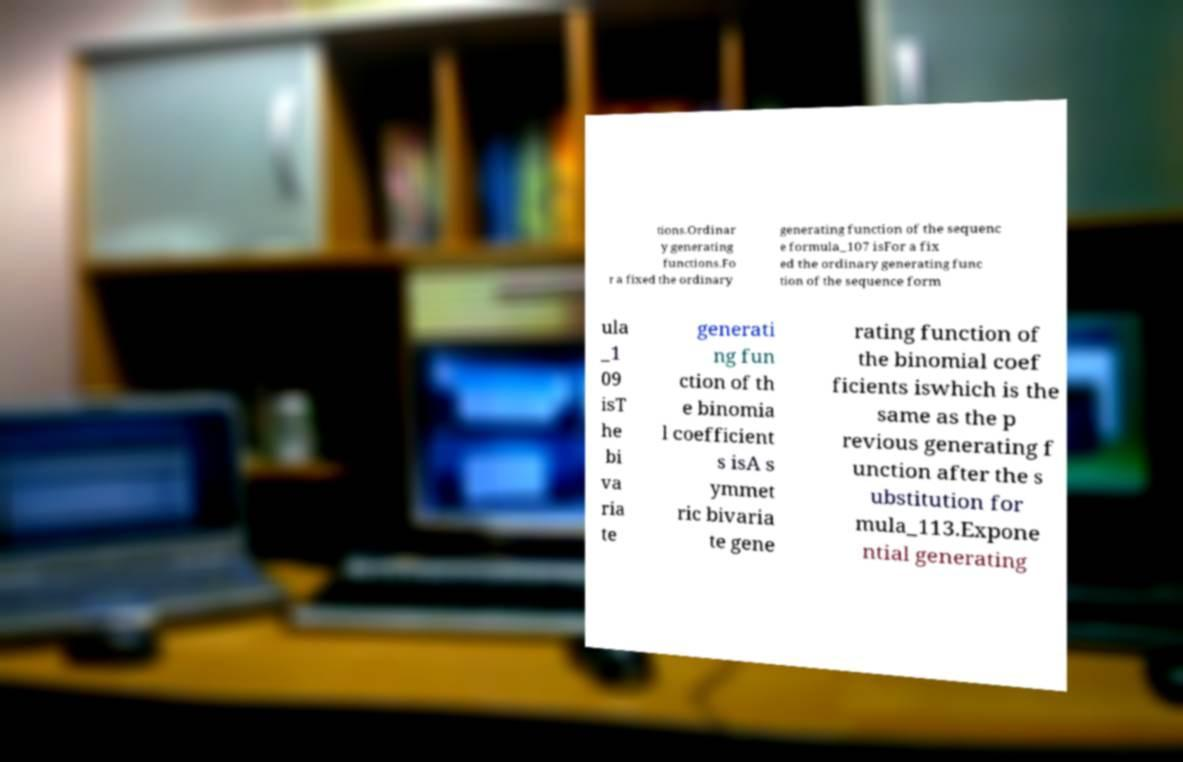Can you read and provide the text displayed in the image?This photo seems to have some interesting text. Can you extract and type it out for me? tions.Ordinar y generating functions.Fo r a fixed the ordinary generating function of the sequenc e formula_107 isFor a fix ed the ordinary generating func tion of the sequence form ula _1 09 isT he bi va ria te generati ng fun ction of th e binomia l coefficient s isA s ymmet ric bivaria te gene rating function of the binomial coef ficients iswhich is the same as the p revious generating f unction after the s ubstitution for mula_113.Expone ntial generating 